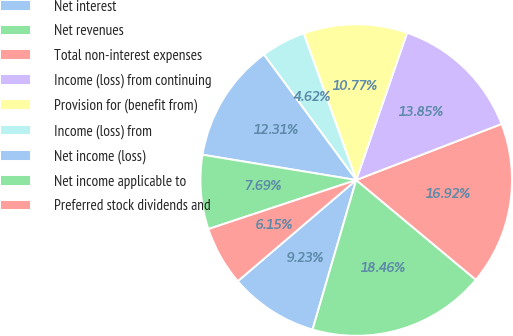Convert chart. <chart><loc_0><loc_0><loc_500><loc_500><pie_chart><fcel>Net interest<fcel>Net revenues<fcel>Total non-interest expenses<fcel>Income (loss) from continuing<fcel>Provision for (benefit from)<fcel>Income (loss) from<fcel>Net income (loss)<fcel>Net income applicable to<fcel>Preferred stock dividends and<nl><fcel>9.23%<fcel>18.46%<fcel>16.92%<fcel>13.85%<fcel>10.77%<fcel>4.62%<fcel>12.31%<fcel>7.69%<fcel>6.15%<nl></chart> 